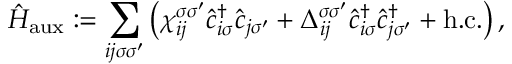Convert formula to latex. <formula><loc_0><loc_0><loc_500><loc_500>\hat { H } _ { a u x } \colon = \sum _ { i j \sigma \sigma ^ { \prime } } \left ( \chi _ { i j } ^ { \sigma \sigma ^ { \prime } } \hat { c } _ { i \sigma } ^ { \dagger } \hat { c } _ { j \sigma ^ { \prime } } + \Delta _ { i j } ^ { \sigma \sigma ^ { \prime } } \hat { c } _ { i \sigma } ^ { \dagger } \hat { c } _ { j \sigma ^ { \prime } } ^ { \dagger } + h . c . \right ) ,</formula> 